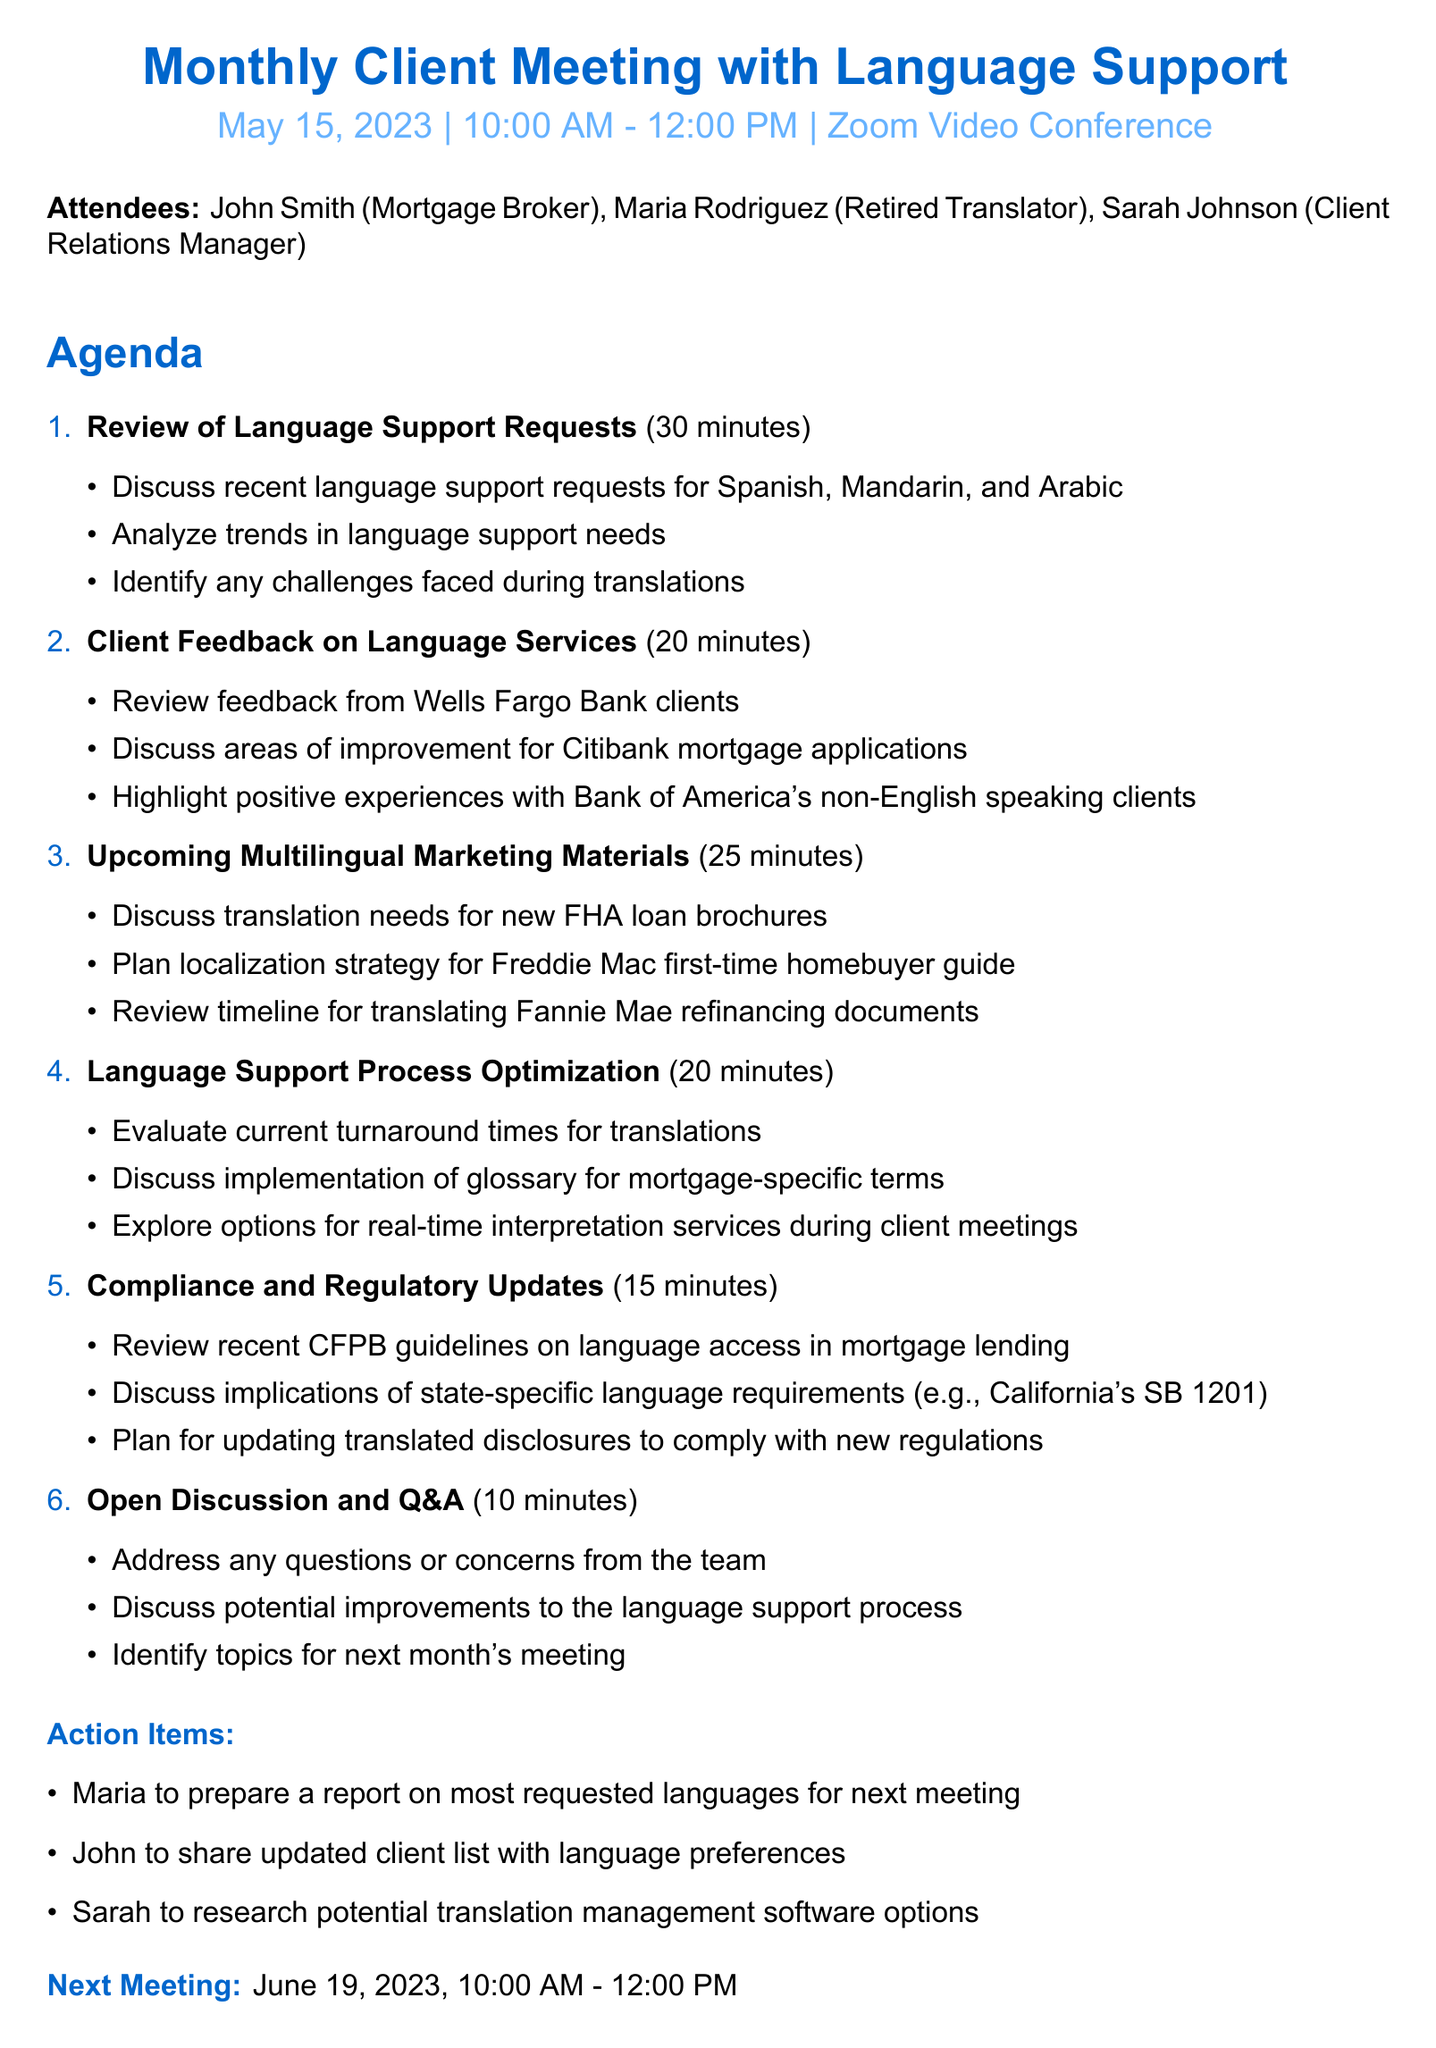What is the meeting title? The meeting title is the heading provided at the beginning of the document, which indicates the focus of the meeting.
Answer: Monthly Client Meeting with Language Support What is the location of the meeting? The location specifies where the meeting will take place and is mentioned in the document.
Answer: Zoom Video Conference Who are the attendees? The attendees section lists all individuals present during the meeting, providing their names and roles.
Answer: John Smith (Mortgage Broker), Maria Rodriguez (Retired Translator), Sarah Johnson (Client Relations Manager) How long is the agenda item for Client Feedback on Language Services? The duration of the agenda items indicates how long each topic will be discussed during the meeting.
Answer: 20 minutes What is one of the action items assigned to Maria? Each action item specifies responsibilities assigned to the attendees for follow-up after the meeting.
Answer: Prepare a report on most requested languages for next meeting What is the date of the next meeting? The next meeting section indicates the date for the following scheduled gathering of the attendees.
Answer: June 19, 2023 What language support trend is discussed in the first agenda item? This requires understanding the details of the first agenda item, focusing on specific languages mentioned in the document.
Answer: Spanish, Mandarin, and Arabic What is the compliance topic covered in the agenda? This entails reasoning what regulations or guidelines are mentioned in the corresponding agenda item.
Answer: CFPB guidelines on language access in mortgage lending What is the duration of the Open Discussion and Q&A item? This question seeks to understand how long the open discussion section of the meeting will be allocated.
Answer: 10 minutes 